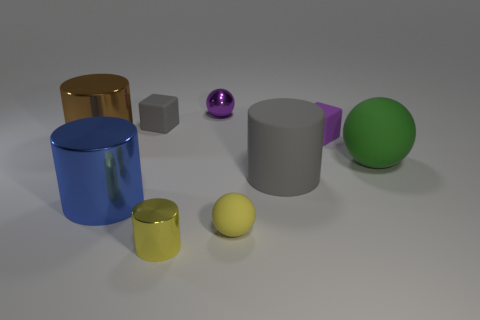Subtract all large brown cylinders. How many cylinders are left? 3 Subtract all purple balls. How many balls are left? 2 Subtract 1 cylinders. How many cylinders are left? 3 Subtract all cubes. How many objects are left? 7 Subtract all red spheres. Subtract all yellow cubes. How many spheres are left? 3 Subtract all brown cylinders. How many green spheres are left? 1 Subtract all yellow metal balls. Subtract all blocks. How many objects are left? 7 Add 1 large brown metal cylinders. How many large brown metal cylinders are left? 2 Add 1 small things. How many small things exist? 6 Subtract 0 blue blocks. How many objects are left? 9 